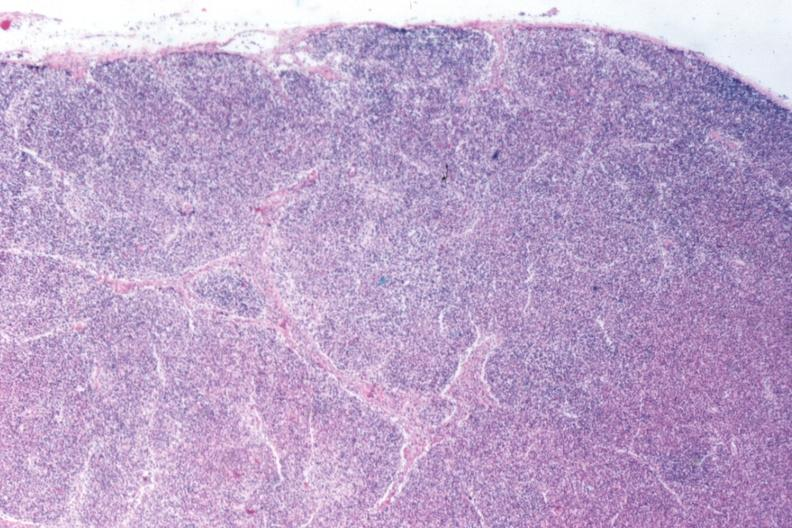s chronic myelogenous leukemia present?
Answer the question using a single word or phrase. Yes 